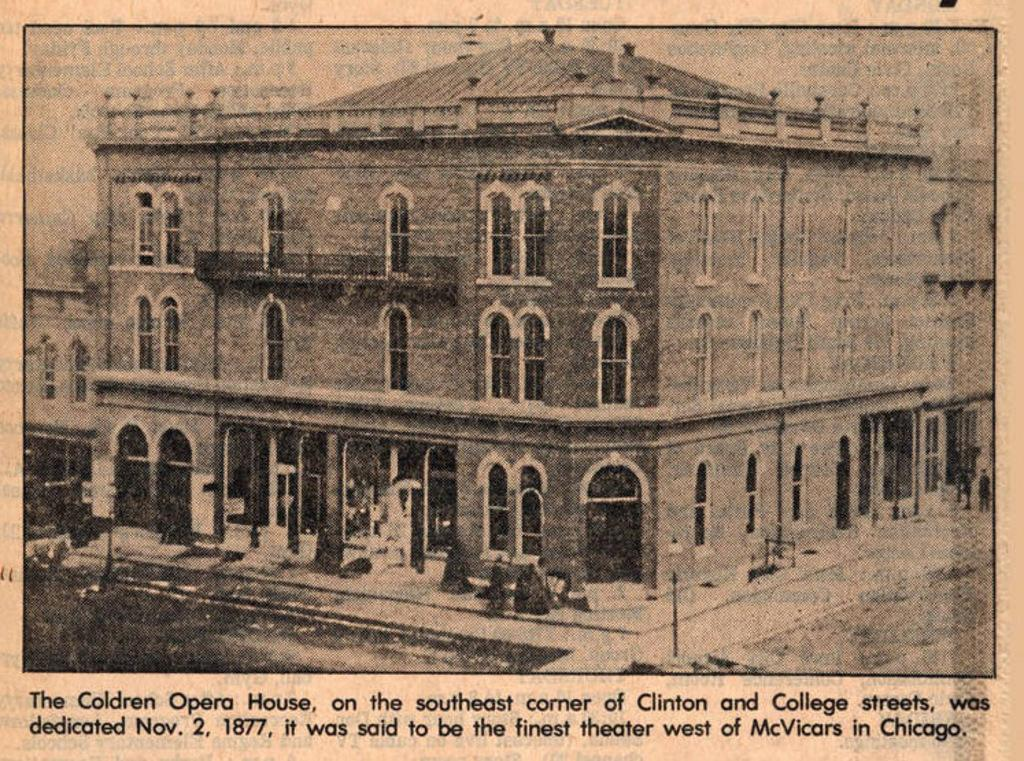What type of structure is visible in the image? There is a building in the image. What can be seen illuminating the area in the image? There are light poles in the image. What are the people in the image doing? People are walking in the image. What is the nature of the text at the bottom of the image? There is edited text on the bottom of the image. How far away is the person crying in the image? There is no person crying in the image. What is the distance between the two steps in the image? There are no steps present in the image. 